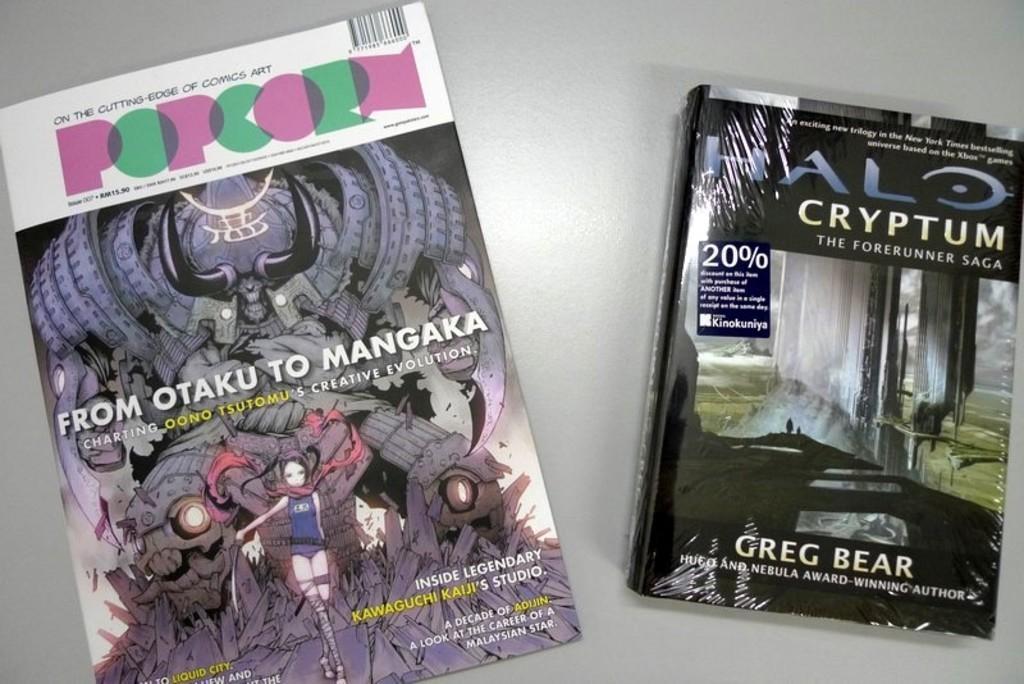Please provide a concise description of this image. In this image I can see two books. On the cover of books I can see some cartoon images and something written on it. These books are on a white color surface. 